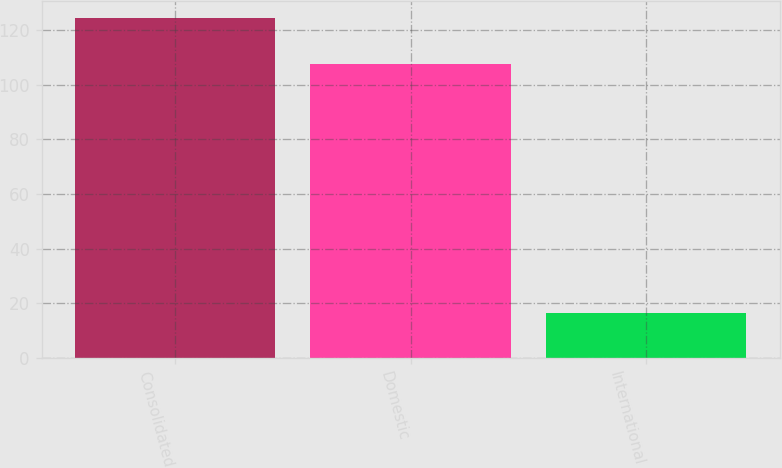<chart> <loc_0><loc_0><loc_500><loc_500><bar_chart><fcel>Consolidated<fcel>Domestic<fcel>International<nl><fcel>124.3<fcel>107.7<fcel>16.6<nl></chart> 